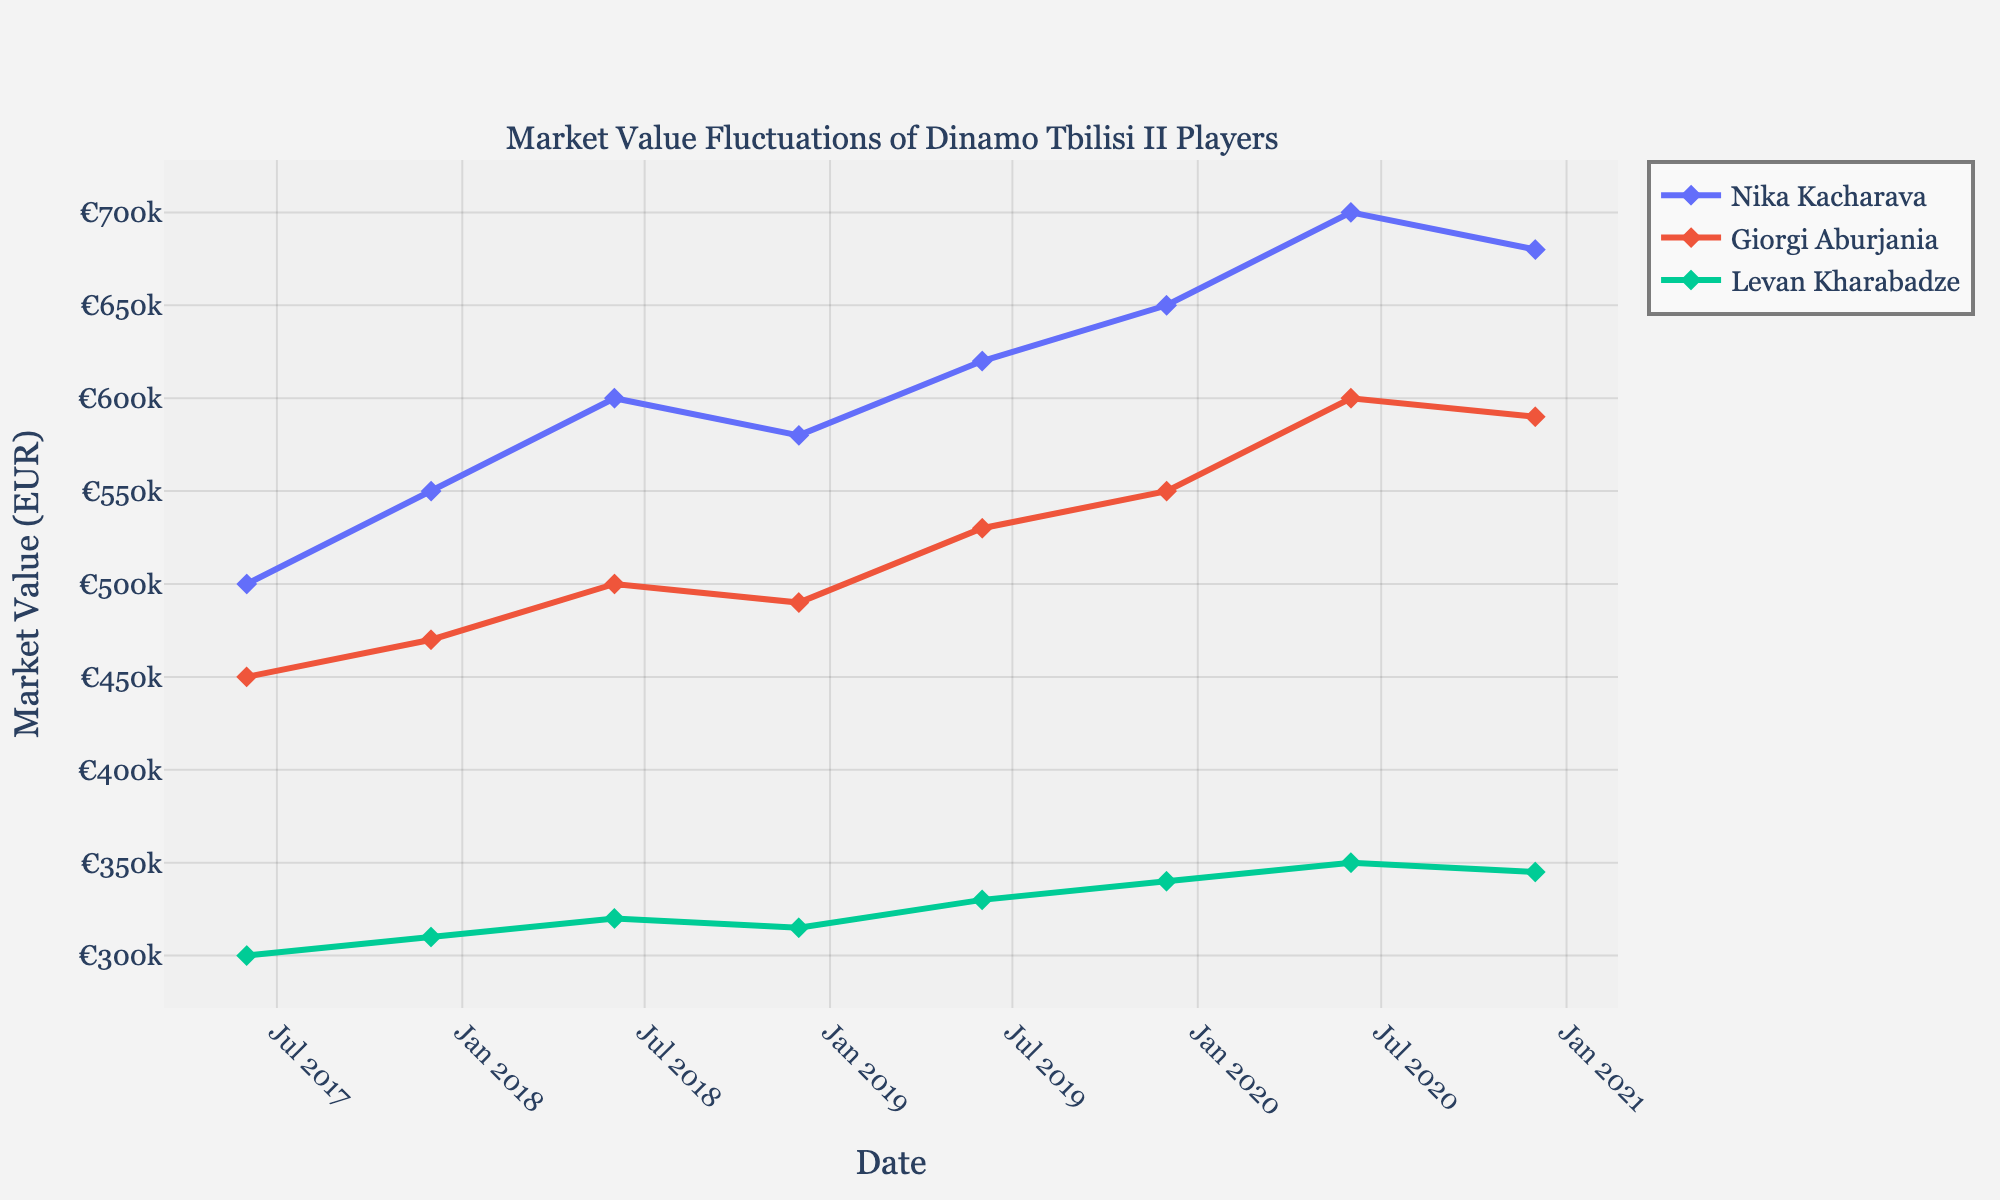What's the title of the figure? The title of the figure is displayed at the top, and it reads "Market Value Fluctuations of Dinamo Tbilisi II Players".
Answer: Market Value Fluctuations of Dinamo Tbilisi II Players Which player had the highest market value in December 2020? From the plot, observe the market values of all players in December 2020 and identify the highest value. Nika Kacharava had the highest market value at €680,000.
Answer: Nika Kacharava How did Giorgi Aburjania's market value change between June 2017 and December 2019? Track Giorgi Aburjania's market value from June 2017 (€450,000) to December 2019 (€550,000). Calculate the difference: €550,000 - €450,000 = €100,000
Answer: Increased by €100,000 Between June 2017 and December 2020, which player had the most stable market value? Evaluate the market value fluctuations for each player over the period. Levan Kharabadze's values show the least change, indicating the most stability.
Answer: Levan Kharabadze What was the average market value of Nika Kacharava in 2019? Observe the market values of Nika Kacharava in June (€620,000) and December (€650,000) 2019. Calculate the average: (€620,000 + €650,000) / 2 = €635,000
Answer: €635,000 Which player experienced the largest drop in market value at any point, and what was the amount of the drop? Identify the steepest decline for each player by calculating differences between consecutive values. Nika Kacharava dropped from €700,000 to €680,000, a drop of €20,000.
Answer: Nika Kacharava, €20,000 Compare the market value trends of Nika Kacharava and Levan Kharabadze from June 2018 to December 2018. Check the values for both players during this period. Nika Kacharava's value decreased from €600,000 to €580,000, while Levan Kharabadze's value decreased from €320,000 to €315,000. Both show a decrease but Kacharava had a larger absolute decrease.
Answer: Both decreased; Nika Kacharava had a larger drop What is the overall trend in the market value for all players from June 2017 to December 2020? Generally, observe the direction of market value lines for each player over the entire period. Overall, there is an upward trend for all players.
Answer: Upward trend Which player had the highest market value in June 2020, and what was that value? Look at the market values for June 2020 and identify the highest value. Nika Kacharava had the highest market value of €700,000.
Answer: Nika Kacharava, €700,000 How did Levan Kharabadze's market value change over the entire period from June 2017 to December 2020? Track Levan Kharabadze's market values from €300,000 in June 2017 to €345,000 in December 2020. Calculate the overall change: €345,000 - €300,000 = €45,000.
Answer: Increased by €45,000 